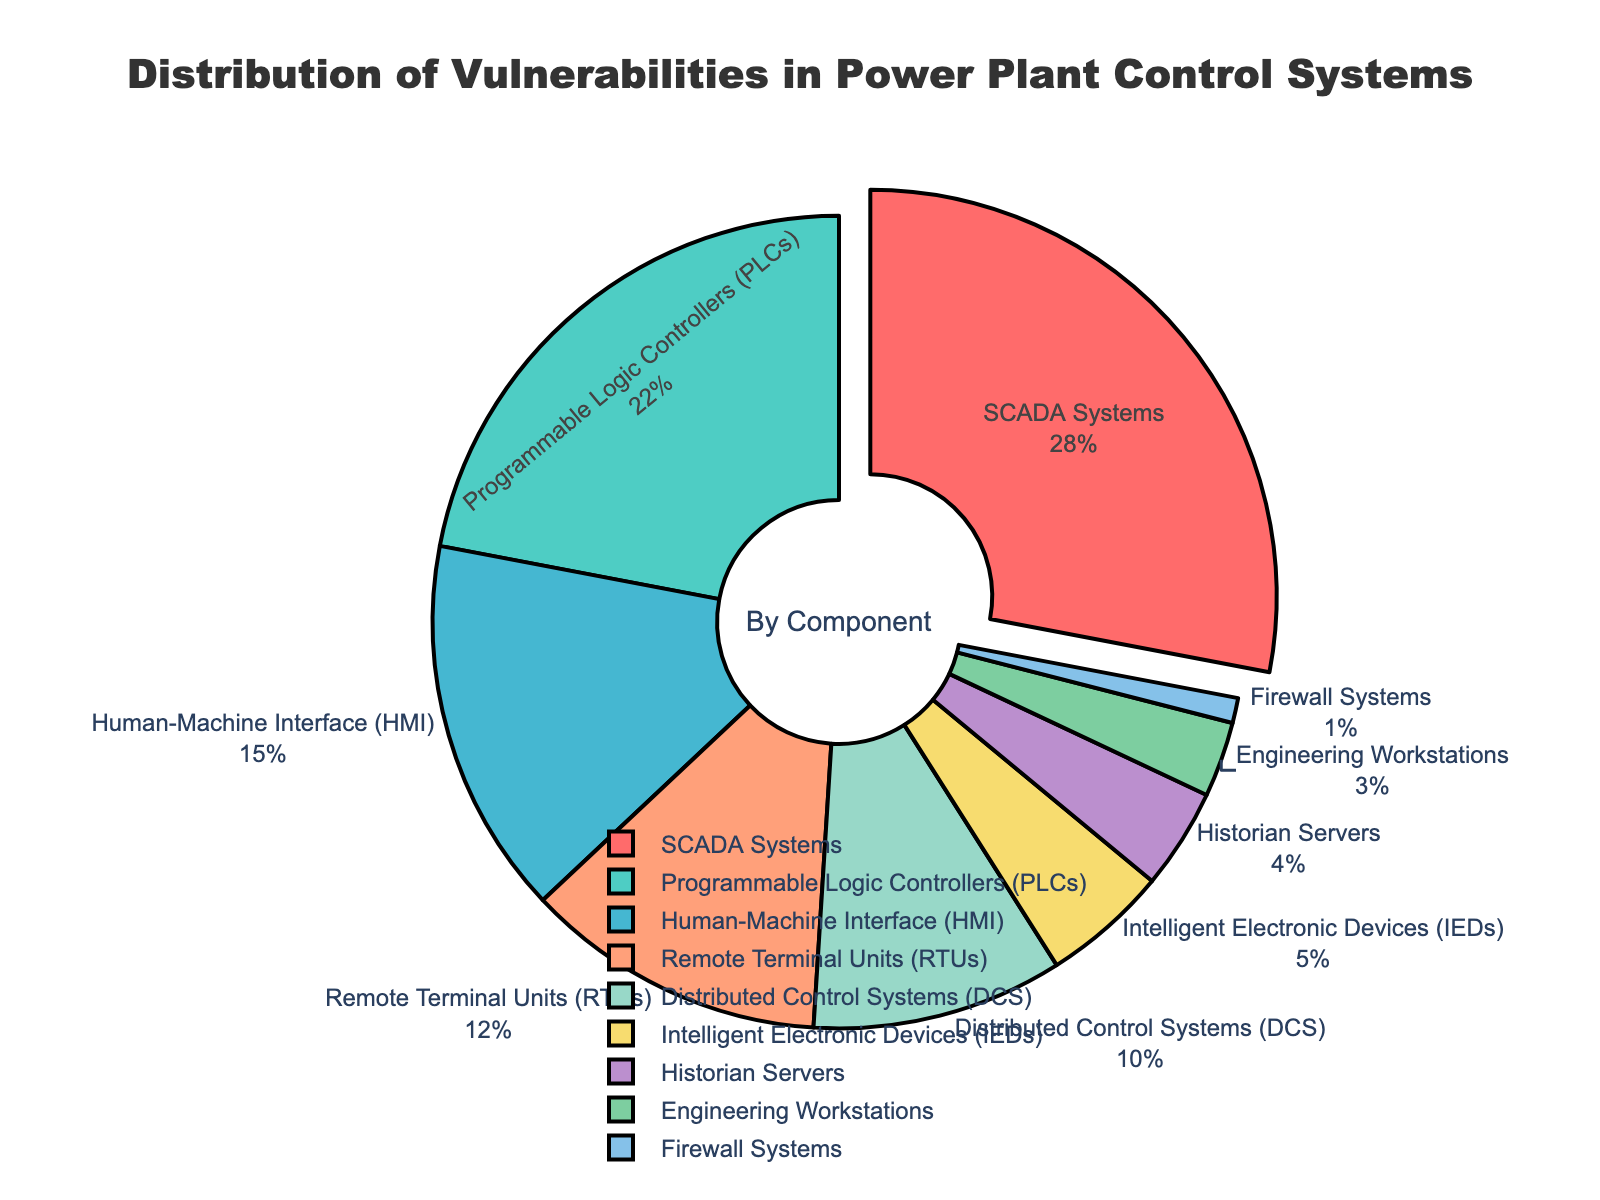What's the percentage of vulnerabilities found in SCADA Systems and Programmable Logic Controllers (PLCs) combined? First, retrieve the individual percentages for SCADA Systems (28%) and PLCs (22%). Then, add these two percentages together: 28 + 22 = 50%.
Answer: 50% Which component has a higher percentage of vulnerabilities: Human-Machine Interface (HMI) or Distributed Control Systems (DCS)? Retrieve the percentages for HMI (15%) and DCS (10%). Compare the two values: 15% is greater than 10%, hence HMI has a higher percentage of vulnerabilities.
Answer: HMI What is the difference in vulnerability distribution percentage between Remote Terminal Units (RTUs) and Intelligent Electronic Devices (IEDs)? Retrieve the percentages for RTUs (12%) and IEDs (5%). Calculate the difference: 12 - 5 = 7%.
Answer: 7% Which components have a percentage less than 10%? Review the pie chart and identify components with percentages less than 10%. These components are Distributed Control Systems (10%), Intelligent Electronic Devices (5%), Historian Servers (4%), Engineering Workstations (3%), and Firewall Systems (1%).
Answer: DCS, IEDs, Historian Servers, Engineering Workstations, Firewall Systems What is the combined percentage of vulnerabilities for the components with the three smallest shares? Identify the three smallest percentages: Firewall Systems (1%), Engineering Workstations (3%), and Historian Servers (4%). Add these percentages together: 1 + 3 + 4 = 8%.
Answer: 8% Which colored segments would you expect to be the largest visually? The largest percentage belongs to SCADA Systems at 28%, so the segment corresponding to SCADA Systems, which is the red segment, would be the largest visually.
Answer: Red segment What is the cumulative percentage of vulnerabilities for Remote Terminal Units (RTUs), Distributed Control Systems (DCS), and Intelligent Electronic Devices (IEDs)? Retrieve the percentages for RTUs (12%), DCS (10%), and IEDs (5%). Add these percentages together: 12 + 10 + 5 = 27%.
Answer: 27% Arrange the components in decreasing order of vulnerabilities percentage. List the components along with their percentages and arrange them in descending order: SCADA Systems (28%), PLCs (22%), HMI (15%), RTUs (12%), DCS (10%), IEDs (5%), Historian Servers (4%), Engineering Workstations (3%), and Firewall Systems (1%).
Answer: SCADA Systems, PLCs, HMI, RTUs, DCS, IEDs, Historian Servers, Engineering Workstations, Firewall Systems 